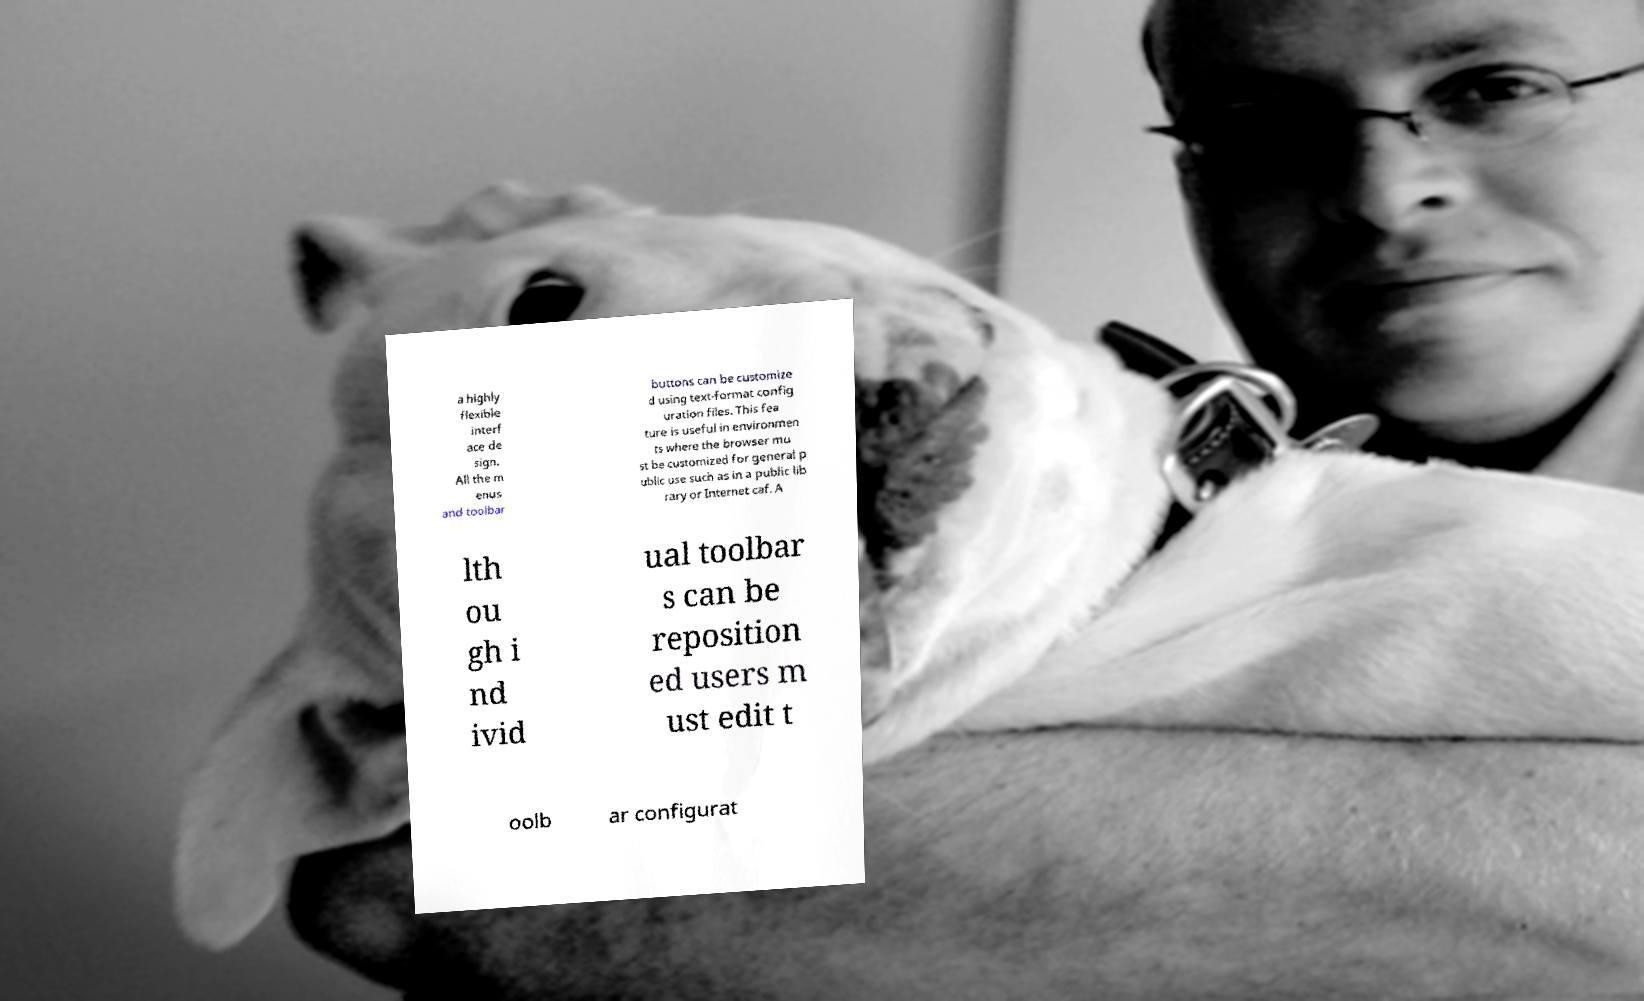I need the written content from this picture converted into text. Can you do that? a highly flexible interf ace de sign. All the m enus and toolbar buttons can be customize d using text-format config uration files. This fea ture is useful in environmen ts where the browser mu st be customized for general p ublic use such as in a public lib rary or Internet caf. A lth ou gh i nd ivid ual toolbar s can be reposition ed users m ust edit t oolb ar configurat 